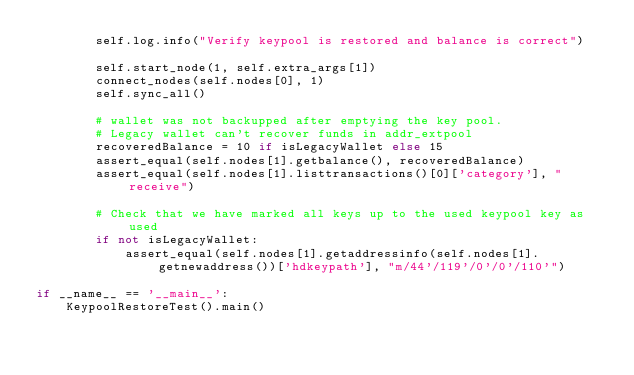<code> <loc_0><loc_0><loc_500><loc_500><_Python_>        self.log.info("Verify keypool is restored and balance is correct")

        self.start_node(1, self.extra_args[1])
        connect_nodes(self.nodes[0], 1)
        self.sync_all()

        # wallet was not backupped after emptying the key pool.
        # Legacy wallet can't recover funds in addr_extpool
        recoveredBalance = 10 if isLegacyWallet else 15
        assert_equal(self.nodes[1].getbalance(), recoveredBalance)
        assert_equal(self.nodes[1].listtransactions()[0]['category'], "receive")

        # Check that we have marked all keys up to the used keypool key as used
        if not isLegacyWallet:
            assert_equal(self.nodes[1].getaddressinfo(self.nodes[1].getnewaddress())['hdkeypath'], "m/44'/119'/0'/0'/110'")

if __name__ == '__main__':
    KeypoolRestoreTest().main()
</code> 